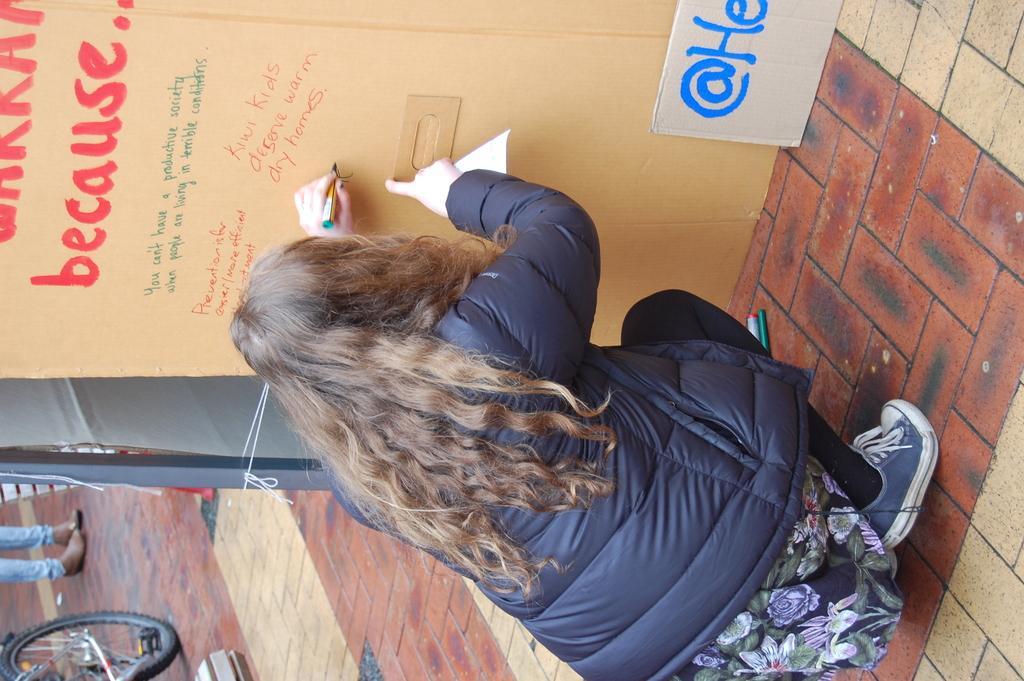Could you give a brief overview of what you see in this image? In this image we can see a woman wearing a dress I standing on the floor holding a pen in her hand. In the background, we can see a person standing and a bicycle placed on the floor and a cardboard with some text on it. 